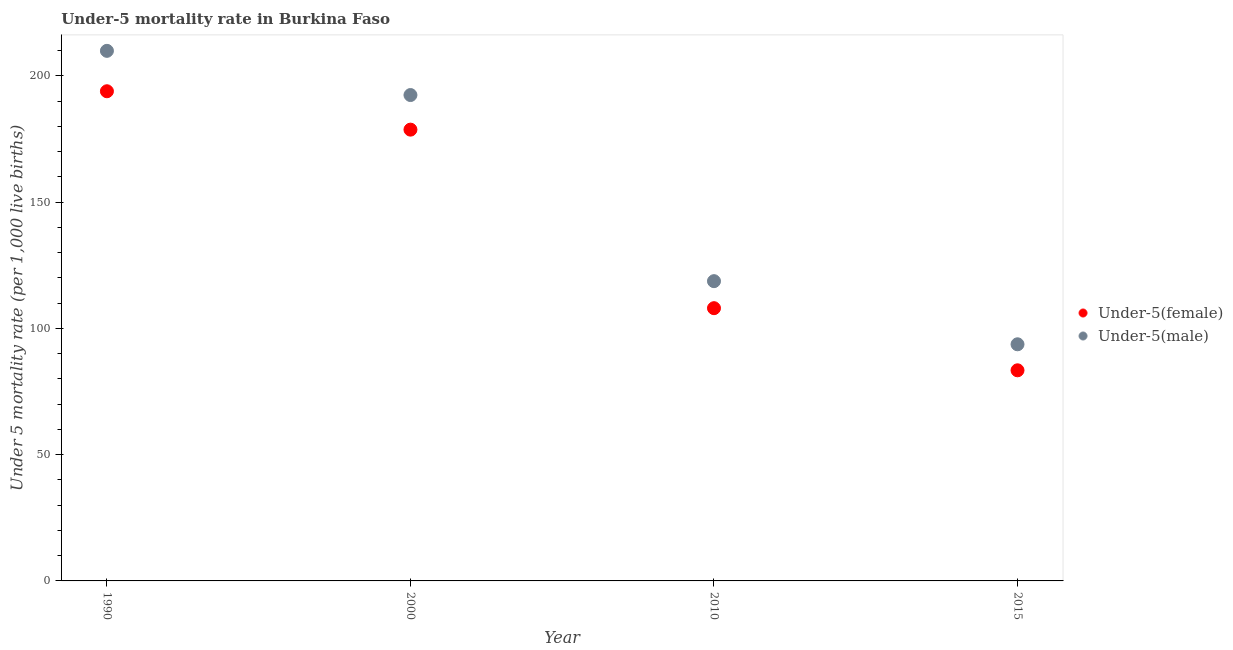Is the number of dotlines equal to the number of legend labels?
Your answer should be very brief. Yes. What is the under-5 male mortality rate in 2000?
Provide a short and direct response. 192.4. Across all years, what is the maximum under-5 male mortality rate?
Provide a short and direct response. 209.9. Across all years, what is the minimum under-5 male mortality rate?
Your answer should be very brief. 93.7. In which year was the under-5 female mortality rate maximum?
Offer a very short reply. 1990. In which year was the under-5 male mortality rate minimum?
Provide a succinct answer. 2015. What is the total under-5 male mortality rate in the graph?
Your response must be concise. 614.7. What is the difference between the under-5 male mortality rate in 2000 and that in 2010?
Keep it short and to the point. 73.7. What is the difference between the under-5 male mortality rate in 2010 and the under-5 female mortality rate in 2000?
Ensure brevity in your answer.  -60. What is the average under-5 female mortality rate per year?
Ensure brevity in your answer.  141. In the year 2015, what is the difference between the under-5 female mortality rate and under-5 male mortality rate?
Make the answer very short. -10.3. What is the ratio of the under-5 male mortality rate in 1990 to that in 2015?
Provide a succinct answer. 2.24. Is the difference between the under-5 female mortality rate in 2000 and 2010 greater than the difference between the under-5 male mortality rate in 2000 and 2010?
Offer a very short reply. No. What is the difference between the highest and the second highest under-5 male mortality rate?
Make the answer very short. 17.5. What is the difference between the highest and the lowest under-5 male mortality rate?
Make the answer very short. 116.2. Is the sum of the under-5 female mortality rate in 1990 and 2010 greater than the maximum under-5 male mortality rate across all years?
Your response must be concise. Yes. Is the under-5 female mortality rate strictly greater than the under-5 male mortality rate over the years?
Your answer should be very brief. No. Is the under-5 male mortality rate strictly less than the under-5 female mortality rate over the years?
Ensure brevity in your answer.  No. How many dotlines are there?
Provide a short and direct response. 2. How many years are there in the graph?
Your response must be concise. 4. What is the difference between two consecutive major ticks on the Y-axis?
Offer a terse response. 50. Where does the legend appear in the graph?
Your response must be concise. Center right. How are the legend labels stacked?
Provide a succinct answer. Vertical. What is the title of the graph?
Keep it short and to the point. Under-5 mortality rate in Burkina Faso. Does "Primary income" appear as one of the legend labels in the graph?
Keep it short and to the point. No. What is the label or title of the Y-axis?
Your answer should be very brief. Under 5 mortality rate (per 1,0 live births). What is the Under 5 mortality rate (per 1,000 live births) in Under-5(female) in 1990?
Give a very brief answer. 193.9. What is the Under 5 mortality rate (per 1,000 live births) of Under-5(male) in 1990?
Offer a terse response. 209.9. What is the Under 5 mortality rate (per 1,000 live births) in Under-5(female) in 2000?
Your answer should be compact. 178.7. What is the Under 5 mortality rate (per 1,000 live births) of Under-5(male) in 2000?
Provide a succinct answer. 192.4. What is the Under 5 mortality rate (per 1,000 live births) of Under-5(female) in 2010?
Your answer should be very brief. 108. What is the Under 5 mortality rate (per 1,000 live births) of Under-5(male) in 2010?
Provide a succinct answer. 118.7. What is the Under 5 mortality rate (per 1,000 live births) in Under-5(female) in 2015?
Offer a very short reply. 83.4. What is the Under 5 mortality rate (per 1,000 live births) in Under-5(male) in 2015?
Your response must be concise. 93.7. Across all years, what is the maximum Under 5 mortality rate (per 1,000 live births) of Under-5(female)?
Provide a succinct answer. 193.9. Across all years, what is the maximum Under 5 mortality rate (per 1,000 live births) of Under-5(male)?
Your answer should be very brief. 209.9. Across all years, what is the minimum Under 5 mortality rate (per 1,000 live births) in Under-5(female)?
Keep it short and to the point. 83.4. Across all years, what is the minimum Under 5 mortality rate (per 1,000 live births) of Under-5(male)?
Ensure brevity in your answer.  93.7. What is the total Under 5 mortality rate (per 1,000 live births) in Under-5(female) in the graph?
Give a very brief answer. 564. What is the total Under 5 mortality rate (per 1,000 live births) of Under-5(male) in the graph?
Your response must be concise. 614.7. What is the difference between the Under 5 mortality rate (per 1,000 live births) of Under-5(male) in 1990 and that in 2000?
Your answer should be very brief. 17.5. What is the difference between the Under 5 mortality rate (per 1,000 live births) of Under-5(female) in 1990 and that in 2010?
Make the answer very short. 85.9. What is the difference between the Under 5 mortality rate (per 1,000 live births) in Under-5(male) in 1990 and that in 2010?
Make the answer very short. 91.2. What is the difference between the Under 5 mortality rate (per 1,000 live births) of Under-5(female) in 1990 and that in 2015?
Offer a terse response. 110.5. What is the difference between the Under 5 mortality rate (per 1,000 live births) of Under-5(male) in 1990 and that in 2015?
Offer a terse response. 116.2. What is the difference between the Under 5 mortality rate (per 1,000 live births) in Under-5(female) in 2000 and that in 2010?
Provide a short and direct response. 70.7. What is the difference between the Under 5 mortality rate (per 1,000 live births) of Under-5(male) in 2000 and that in 2010?
Offer a very short reply. 73.7. What is the difference between the Under 5 mortality rate (per 1,000 live births) in Under-5(female) in 2000 and that in 2015?
Your answer should be very brief. 95.3. What is the difference between the Under 5 mortality rate (per 1,000 live births) of Under-5(male) in 2000 and that in 2015?
Your response must be concise. 98.7. What is the difference between the Under 5 mortality rate (per 1,000 live births) of Under-5(female) in 2010 and that in 2015?
Give a very brief answer. 24.6. What is the difference between the Under 5 mortality rate (per 1,000 live births) of Under-5(female) in 1990 and the Under 5 mortality rate (per 1,000 live births) of Under-5(male) in 2010?
Ensure brevity in your answer.  75.2. What is the difference between the Under 5 mortality rate (per 1,000 live births) of Under-5(female) in 1990 and the Under 5 mortality rate (per 1,000 live births) of Under-5(male) in 2015?
Ensure brevity in your answer.  100.2. What is the difference between the Under 5 mortality rate (per 1,000 live births) in Under-5(female) in 2000 and the Under 5 mortality rate (per 1,000 live births) in Under-5(male) in 2010?
Offer a very short reply. 60. What is the difference between the Under 5 mortality rate (per 1,000 live births) in Under-5(female) in 2000 and the Under 5 mortality rate (per 1,000 live births) in Under-5(male) in 2015?
Provide a short and direct response. 85. What is the average Under 5 mortality rate (per 1,000 live births) of Under-5(female) per year?
Provide a short and direct response. 141. What is the average Under 5 mortality rate (per 1,000 live births) of Under-5(male) per year?
Provide a succinct answer. 153.68. In the year 1990, what is the difference between the Under 5 mortality rate (per 1,000 live births) of Under-5(female) and Under 5 mortality rate (per 1,000 live births) of Under-5(male)?
Offer a very short reply. -16. In the year 2000, what is the difference between the Under 5 mortality rate (per 1,000 live births) in Under-5(female) and Under 5 mortality rate (per 1,000 live births) in Under-5(male)?
Offer a very short reply. -13.7. In the year 2015, what is the difference between the Under 5 mortality rate (per 1,000 live births) of Under-5(female) and Under 5 mortality rate (per 1,000 live births) of Under-5(male)?
Your answer should be compact. -10.3. What is the ratio of the Under 5 mortality rate (per 1,000 live births) of Under-5(female) in 1990 to that in 2000?
Offer a terse response. 1.09. What is the ratio of the Under 5 mortality rate (per 1,000 live births) in Under-5(male) in 1990 to that in 2000?
Make the answer very short. 1.09. What is the ratio of the Under 5 mortality rate (per 1,000 live births) of Under-5(female) in 1990 to that in 2010?
Offer a very short reply. 1.8. What is the ratio of the Under 5 mortality rate (per 1,000 live births) in Under-5(male) in 1990 to that in 2010?
Keep it short and to the point. 1.77. What is the ratio of the Under 5 mortality rate (per 1,000 live births) of Under-5(female) in 1990 to that in 2015?
Your response must be concise. 2.32. What is the ratio of the Under 5 mortality rate (per 1,000 live births) of Under-5(male) in 1990 to that in 2015?
Keep it short and to the point. 2.24. What is the ratio of the Under 5 mortality rate (per 1,000 live births) of Under-5(female) in 2000 to that in 2010?
Give a very brief answer. 1.65. What is the ratio of the Under 5 mortality rate (per 1,000 live births) of Under-5(male) in 2000 to that in 2010?
Offer a very short reply. 1.62. What is the ratio of the Under 5 mortality rate (per 1,000 live births) in Under-5(female) in 2000 to that in 2015?
Your response must be concise. 2.14. What is the ratio of the Under 5 mortality rate (per 1,000 live births) of Under-5(male) in 2000 to that in 2015?
Give a very brief answer. 2.05. What is the ratio of the Under 5 mortality rate (per 1,000 live births) in Under-5(female) in 2010 to that in 2015?
Keep it short and to the point. 1.29. What is the ratio of the Under 5 mortality rate (per 1,000 live births) in Under-5(male) in 2010 to that in 2015?
Make the answer very short. 1.27. What is the difference between the highest and the lowest Under 5 mortality rate (per 1,000 live births) in Under-5(female)?
Your answer should be very brief. 110.5. What is the difference between the highest and the lowest Under 5 mortality rate (per 1,000 live births) of Under-5(male)?
Keep it short and to the point. 116.2. 